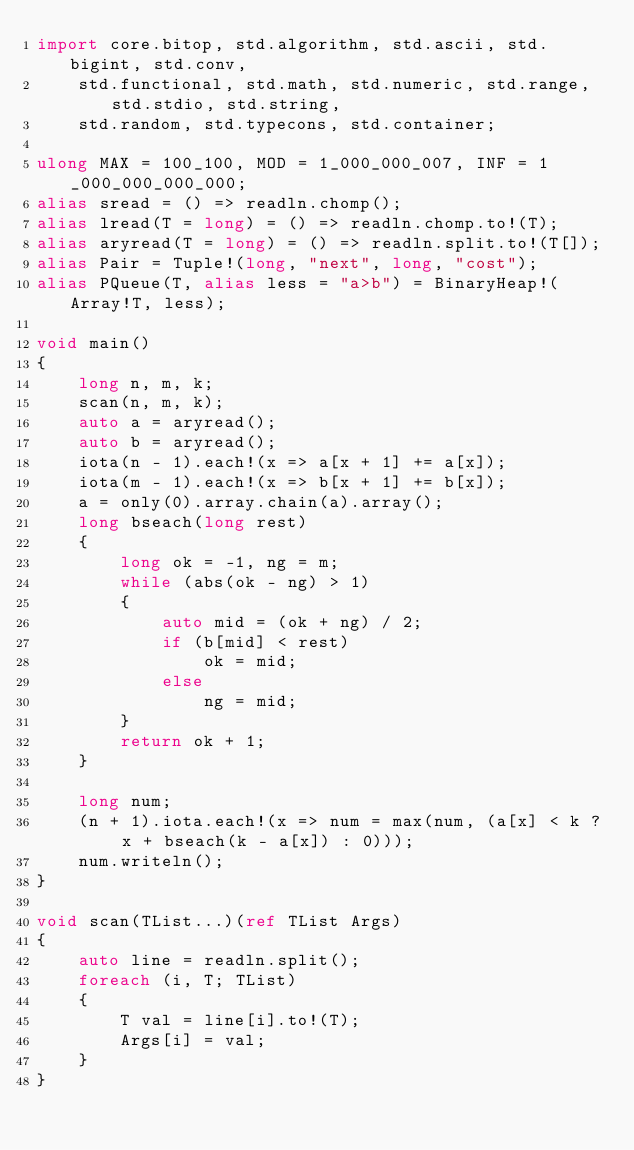Convert code to text. <code><loc_0><loc_0><loc_500><loc_500><_D_>import core.bitop, std.algorithm, std.ascii, std.bigint, std.conv,
    std.functional, std.math, std.numeric, std.range, std.stdio, std.string,
    std.random, std.typecons, std.container;

ulong MAX = 100_100, MOD = 1_000_000_007, INF = 1_000_000_000_000;
alias sread = () => readln.chomp();
alias lread(T = long) = () => readln.chomp.to!(T);
alias aryread(T = long) = () => readln.split.to!(T[]);
alias Pair = Tuple!(long, "next", long, "cost");
alias PQueue(T, alias less = "a>b") = BinaryHeap!(Array!T, less);

void main()
{
    long n, m, k;
    scan(n, m, k);
    auto a = aryread();
    auto b = aryread();
    iota(n - 1).each!(x => a[x + 1] += a[x]);
    iota(m - 1).each!(x => b[x + 1] += b[x]);
    a = only(0).array.chain(a).array();
    long bseach(long rest)
    {
        long ok = -1, ng = m;
        while (abs(ok - ng) > 1)
        {
            auto mid = (ok + ng) / 2;
            if (b[mid] < rest)
                ok = mid;
            else
                ng = mid;
        }
        return ok + 1;
    }

    long num;
    (n + 1).iota.each!(x => num = max(num, (a[x] < k ? x + bseach(k - a[x]) : 0)));
    num.writeln();
}

void scan(TList...)(ref TList Args)
{
    auto line = readln.split();
    foreach (i, T; TList)
    {
        T val = line[i].to!(T);
        Args[i] = val;
    }
}
</code> 